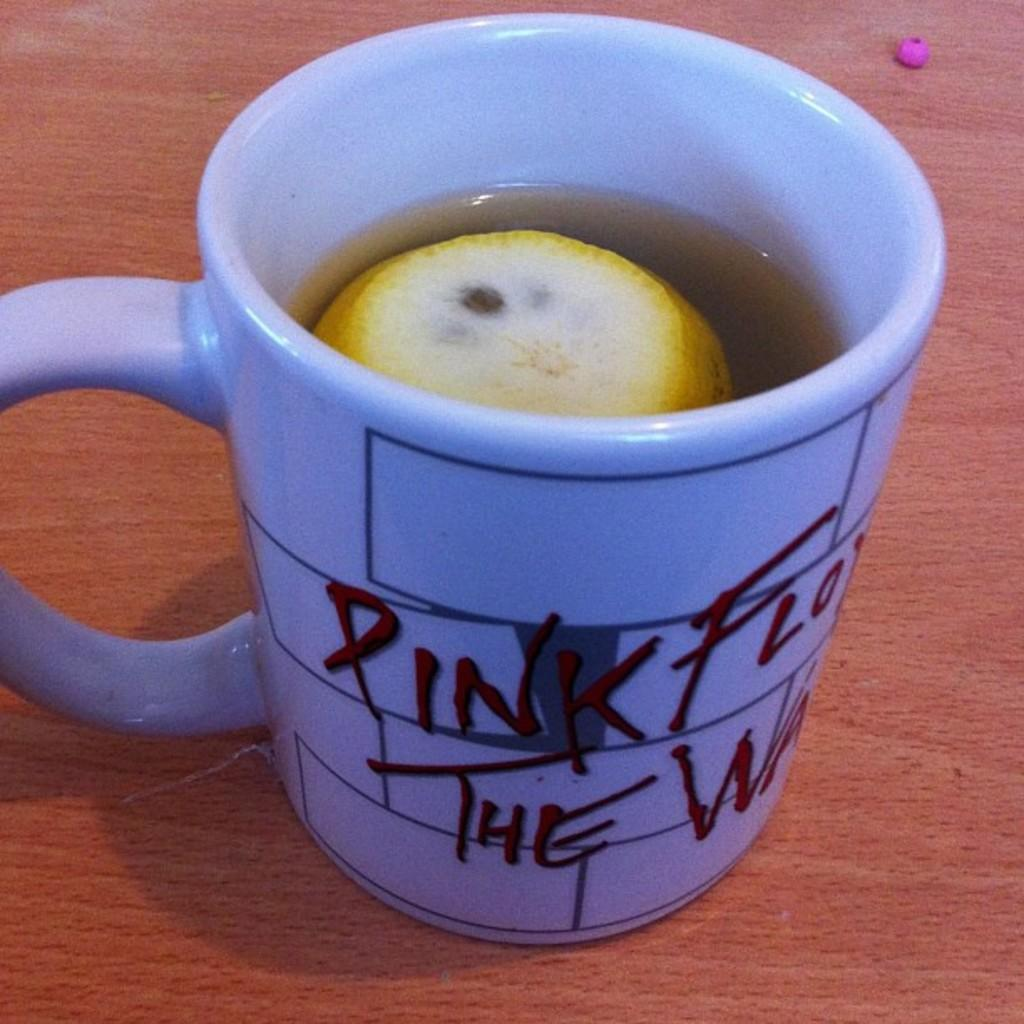<image>
Share a concise interpretation of the image provided. A ceramic coffee cup displays the familiar cinderblock logo for Pink Floyd The Wall. 